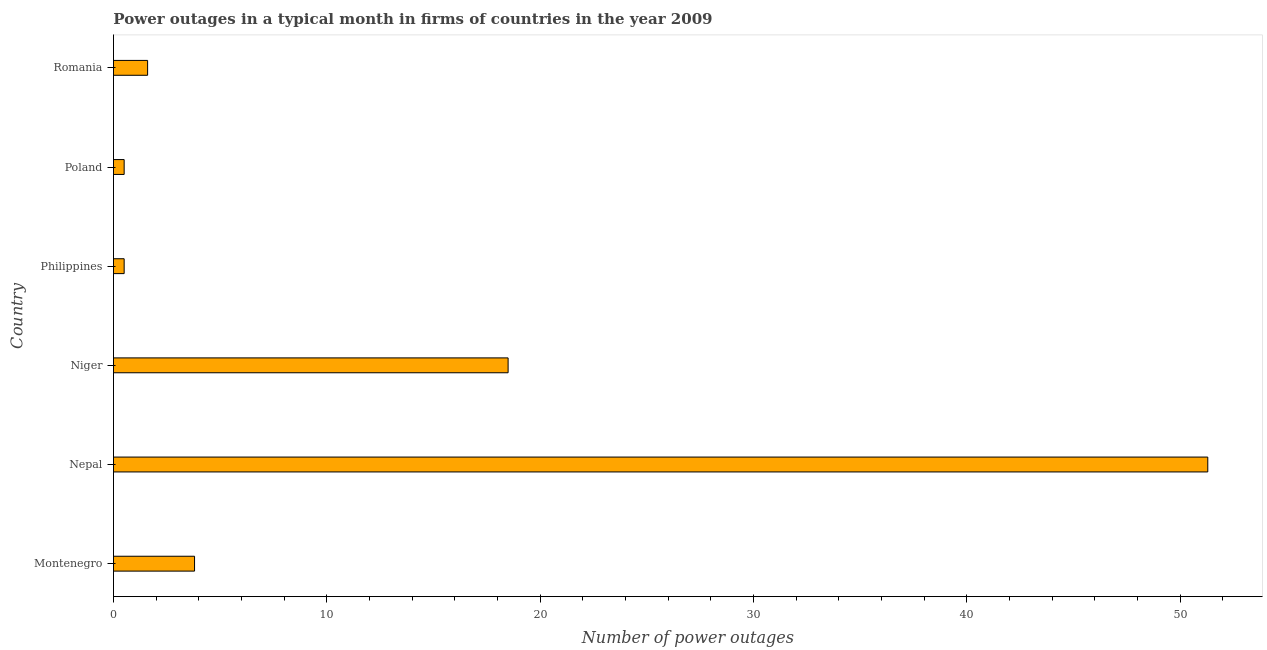Does the graph contain grids?
Give a very brief answer. No. What is the title of the graph?
Your answer should be compact. Power outages in a typical month in firms of countries in the year 2009. What is the label or title of the X-axis?
Your answer should be very brief. Number of power outages. What is the label or title of the Y-axis?
Offer a terse response. Country. What is the number of power outages in Nepal?
Your response must be concise. 51.3. Across all countries, what is the maximum number of power outages?
Your answer should be compact. 51.3. In which country was the number of power outages maximum?
Offer a very short reply. Nepal. What is the sum of the number of power outages?
Your answer should be very brief. 76.2. What is the difference between the number of power outages in Nepal and Philippines?
Your answer should be compact. 50.8. What is the average number of power outages per country?
Your answer should be very brief. 12.7. In how many countries, is the number of power outages greater than 46 ?
Keep it short and to the point. 1. What is the ratio of the number of power outages in Niger to that in Poland?
Provide a short and direct response. 37. Is the difference between the number of power outages in Philippines and Poland greater than the difference between any two countries?
Provide a succinct answer. No. What is the difference between the highest and the second highest number of power outages?
Offer a very short reply. 32.8. What is the difference between the highest and the lowest number of power outages?
Offer a very short reply. 50.8. In how many countries, is the number of power outages greater than the average number of power outages taken over all countries?
Your answer should be very brief. 2. How many bars are there?
Your answer should be compact. 6. How many countries are there in the graph?
Provide a succinct answer. 6. What is the difference between two consecutive major ticks on the X-axis?
Your answer should be compact. 10. Are the values on the major ticks of X-axis written in scientific E-notation?
Provide a short and direct response. No. What is the Number of power outages in Nepal?
Ensure brevity in your answer.  51.3. What is the Number of power outages in Niger?
Provide a succinct answer. 18.5. What is the Number of power outages in Philippines?
Make the answer very short. 0.5. What is the Number of power outages in Romania?
Offer a terse response. 1.6. What is the difference between the Number of power outages in Montenegro and Nepal?
Offer a terse response. -47.5. What is the difference between the Number of power outages in Montenegro and Niger?
Keep it short and to the point. -14.7. What is the difference between the Number of power outages in Montenegro and Philippines?
Your answer should be very brief. 3.3. What is the difference between the Number of power outages in Montenegro and Romania?
Make the answer very short. 2.2. What is the difference between the Number of power outages in Nepal and Niger?
Offer a terse response. 32.8. What is the difference between the Number of power outages in Nepal and Philippines?
Give a very brief answer. 50.8. What is the difference between the Number of power outages in Nepal and Poland?
Make the answer very short. 50.8. What is the difference between the Number of power outages in Nepal and Romania?
Your answer should be very brief. 49.7. What is the difference between the Number of power outages in Niger and Philippines?
Keep it short and to the point. 18. What is the difference between the Number of power outages in Niger and Poland?
Offer a terse response. 18. What is the difference between the Number of power outages in Niger and Romania?
Offer a terse response. 16.9. What is the difference between the Number of power outages in Philippines and Poland?
Ensure brevity in your answer.  0. What is the difference between the Number of power outages in Philippines and Romania?
Your answer should be very brief. -1.1. What is the difference between the Number of power outages in Poland and Romania?
Give a very brief answer. -1.1. What is the ratio of the Number of power outages in Montenegro to that in Nepal?
Your answer should be very brief. 0.07. What is the ratio of the Number of power outages in Montenegro to that in Niger?
Offer a very short reply. 0.2. What is the ratio of the Number of power outages in Montenegro to that in Philippines?
Offer a terse response. 7.6. What is the ratio of the Number of power outages in Montenegro to that in Poland?
Your answer should be very brief. 7.6. What is the ratio of the Number of power outages in Montenegro to that in Romania?
Provide a succinct answer. 2.38. What is the ratio of the Number of power outages in Nepal to that in Niger?
Your answer should be compact. 2.77. What is the ratio of the Number of power outages in Nepal to that in Philippines?
Your answer should be compact. 102.6. What is the ratio of the Number of power outages in Nepal to that in Poland?
Keep it short and to the point. 102.6. What is the ratio of the Number of power outages in Nepal to that in Romania?
Provide a short and direct response. 32.06. What is the ratio of the Number of power outages in Niger to that in Poland?
Your answer should be compact. 37. What is the ratio of the Number of power outages in Niger to that in Romania?
Make the answer very short. 11.56. What is the ratio of the Number of power outages in Philippines to that in Poland?
Give a very brief answer. 1. What is the ratio of the Number of power outages in Philippines to that in Romania?
Ensure brevity in your answer.  0.31. What is the ratio of the Number of power outages in Poland to that in Romania?
Ensure brevity in your answer.  0.31. 